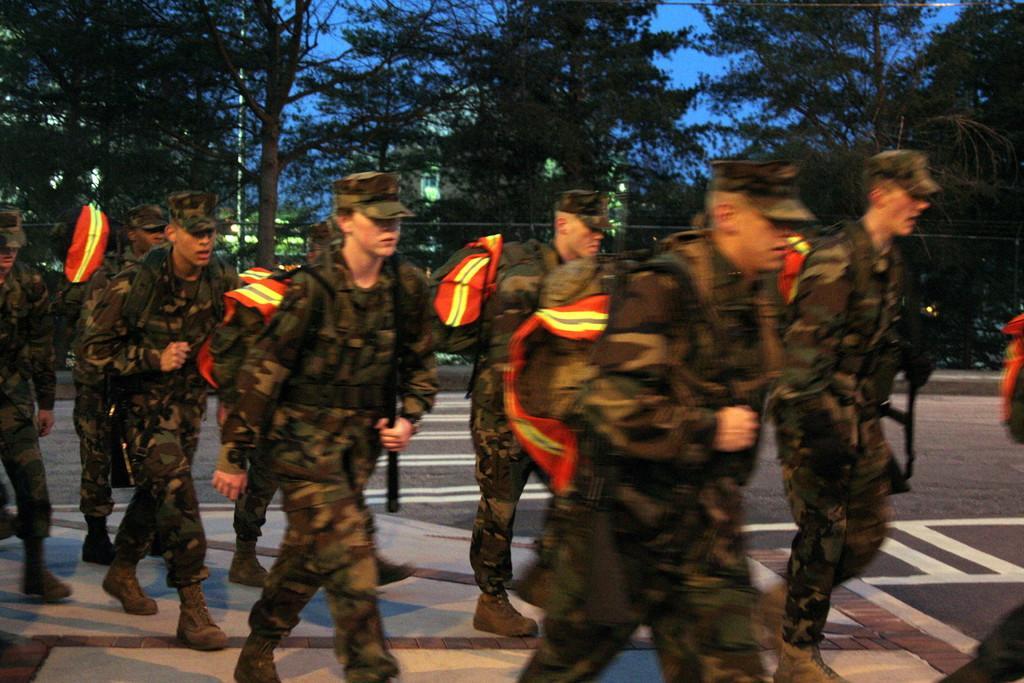Can you describe this image briefly? In this image we can see men wearing uniform and walking on the road. In the background there are buildings, electric lights, trees and sky. 